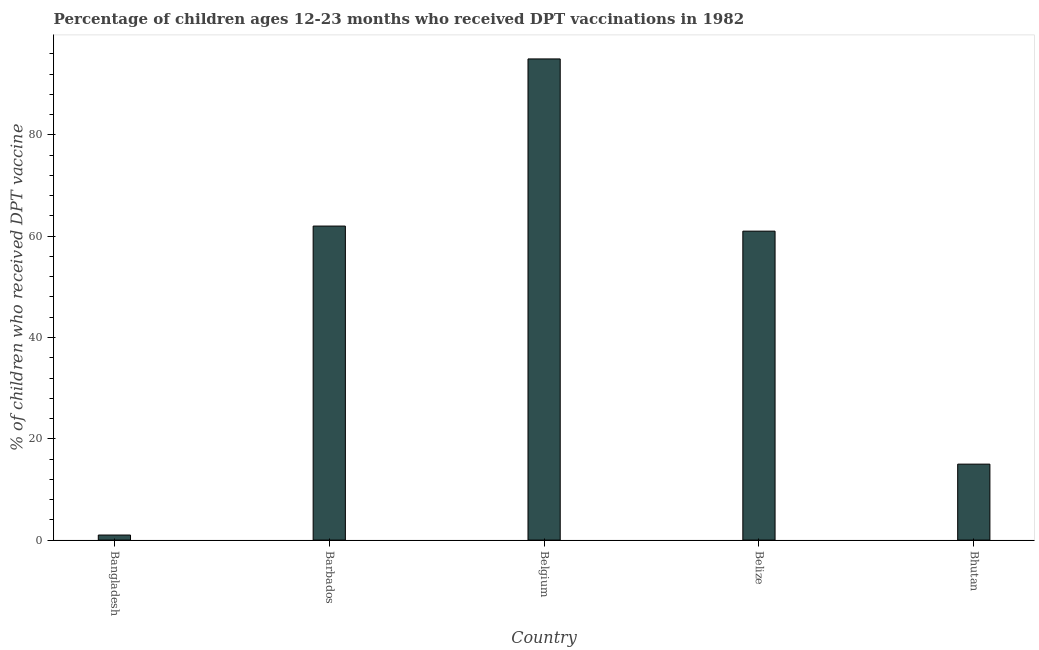Does the graph contain any zero values?
Ensure brevity in your answer.  No. Does the graph contain grids?
Your response must be concise. No. What is the title of the graph?
Keep it short and to the point. Percentage of children ages 12-23 months who received DPT vaccinations in 1982. What is the label or title of the Y-axis?
Ensure brevity in your answer.  % of children who received DPT vaccine. Across all countries, what is the maximum percentage of children who received dpt vaccine?
Make the answer very short. 95. In which country was the percentage of children who received dpt vaccine minimum?
Your response must be concise. Bangladesh. What is the sum of the percentage of children who received dpt vaccine?
Your answer should be very brief. 234. What is the difference between the percentage of children who received dpt vaccine in Bangladesh and Belgium?
Your answer should be compact. -94. What is the average percentage of children who received dpt vaccine per country?
Provide a short and direct response. 46.8. In how many countries, is the percentage of children who received dpt vaccine greater than 84 %?
Your answer should be very brief. 1. What is the ratio of the percentage of children who received dpt vaccine in Bangladesh to that in Belgium?
Provide a succinct answer. 0.01. Is the difference between the percentage of children who received dpt vaccine in Belgium and Belize greater than the difference between any two countries?
Offer a terse response. No. What is the difference between the highest and the second highest percentage of children who received dpt vaccine?
Provide a succinct answer. 33. What is the difference between the highest and the lowest percentage of children who received dpt vaccine?
Keep it short and to the point. 94. In how many countries, is the percentage of children who received dpt vaccine greater than the average percentage of children who received dpt vaccine taken over all countries?
Your answer should be compact. 3. Are all the bars in the graph horizontal?
Ensure brevity in your answer.  No. What is the difference between two consecutive major ticks on the Y-axis?
Offer a terse response. 20. What is the % of children who received DPT vaccine of Bangladesh?
Your answer should be very brief. 1. What is the % of children who received DPT vaccine in Barbados?
Give a very brief answer. 62. What is the % of children who received DPT vaccine in Belgium?
Your response must be concise. 95. What is the % of children who received DPT vaccine in Belize?
Your response must be concise. 61. What is the % of children who received DPT vaccine of Bhutan?
Keep it short and to the point. 15. What is the difference between the % of children who received DPT vaccine in Bangladesh and Barbados?
Offer a terse response. -61. What is the difference between the % of children who received DPT vaccine in Bangladesh and Belgium?
Your response must be concise. -94. What is the difference between the % of children who received DPT vaccine in Bangladesh and Belize?
Your answer should be very brief. -60. What is the difference between the % of children who received DPT vaccine in Bangladesh and Bhutan?
Your response must be concise. -14. What is the difference between the % of children who received DPT vaccine in Barbados and Belgium?
Keep it short and to the point. -33. What is the difference between the % of children who received DPT vaccine in Barbados and Belize?
Provide a short and direct response. 1. What is the difference between the % of children who received DPT vaccine in Belgium and Bhutan?
Make the answer very short. 80. What is the ratio of the % of children who received DPT vaccine in Bangladesh to that in Barbados?
Your response must be concise. 0.02. What is the ratio of the % of children who received DPT vaccine in Bangladesh to that in Belgium?
Keep it short and to the point. 0.01. What is the ratio of the % of children who received DPT vaccine in Bangladesh to that in Belize?
Keep it short and to the point. 0.02. What is the ratio of the % of children who received DPT vaccine in Bangladesh to that in Bhutan?
Give a very brief answer. 0.07. What is the ratio of the % of children who received DPT vaccine in Barbados to that in Belgium?
Ensure brevity in your answer.  0.65. What is the ratio of the % of children who received DPT vaccine in Barbados to that in Bhutan?
Keep it short and to the point. 4.13. What is the ratio of the % of children who received DPT vaccine in Belgium to that in Belize?
Provide a succinct answer. 1.56. What is the ratio of the % of children who received DPT vaccine in Belgium to that in Bhutan?
Your response must be concise. 6.33. What is the ratio of the % of children who received DPT vaccine in Belize to that in Bhutan?
Keep it short and to the point. 4.07. 